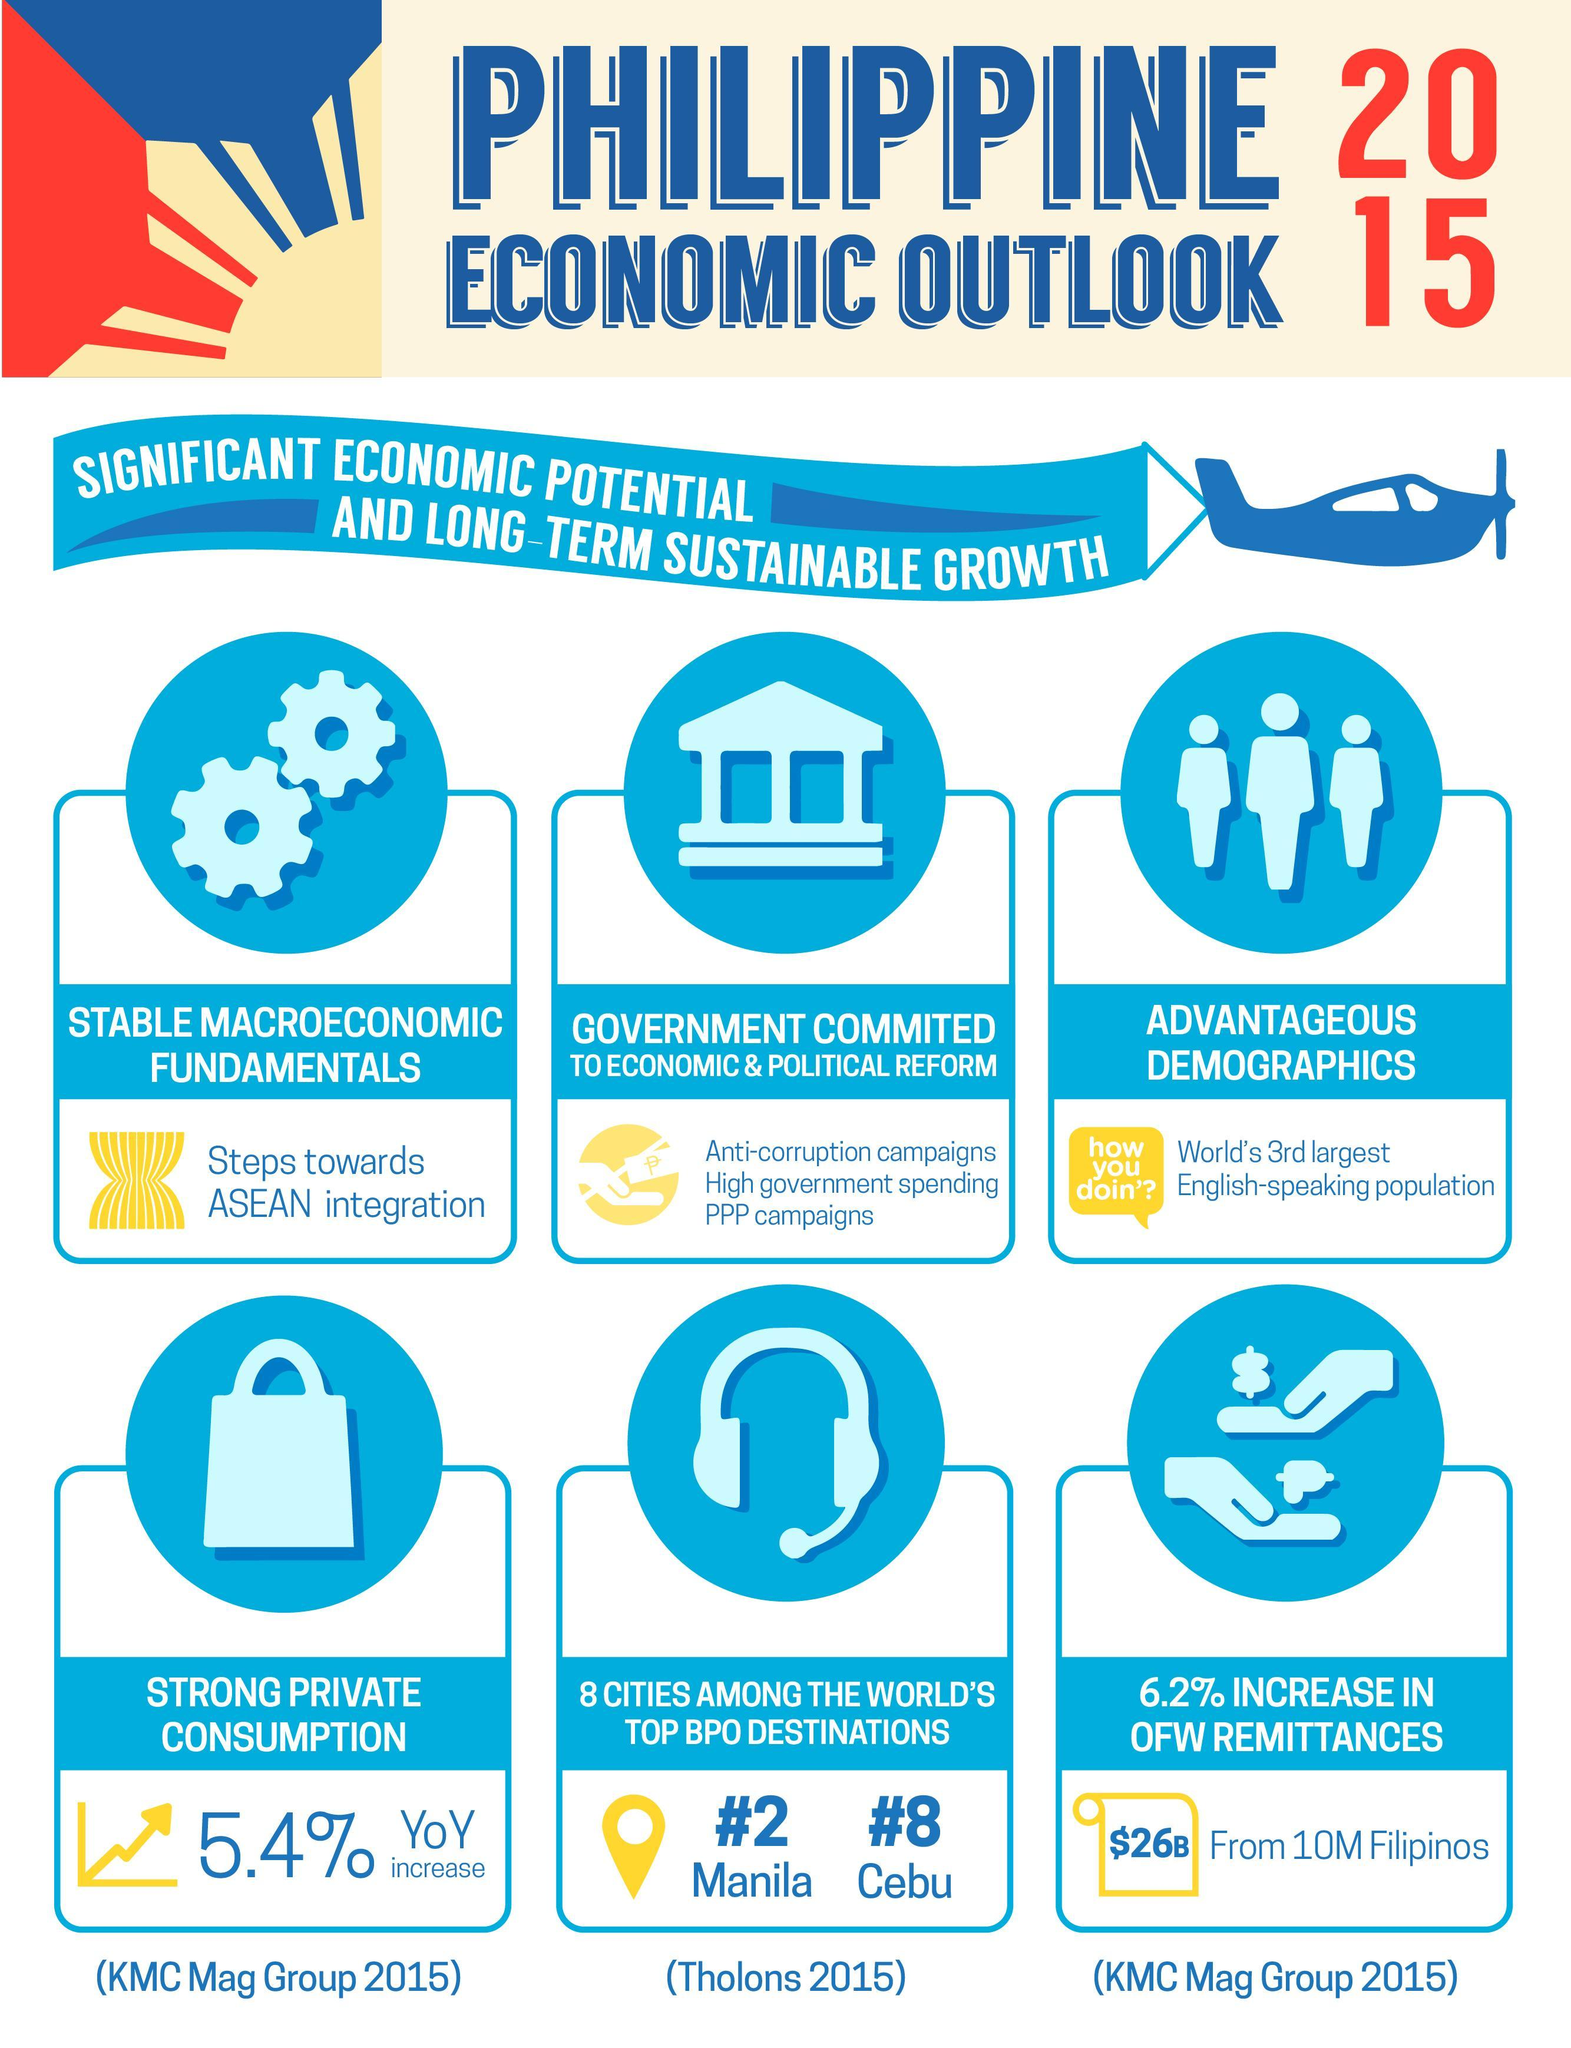How many airplane icons are in this infographic?
Answer the question with a short phrase. 1 How many points about the Philippines ' economy is in this infographic? 6 What is the third point about the Philippines ' economy is in this infographic? Advantageous Demographics How many hands are in this infographic? 2 What is the number of icons of the people are in the infographic? 3 